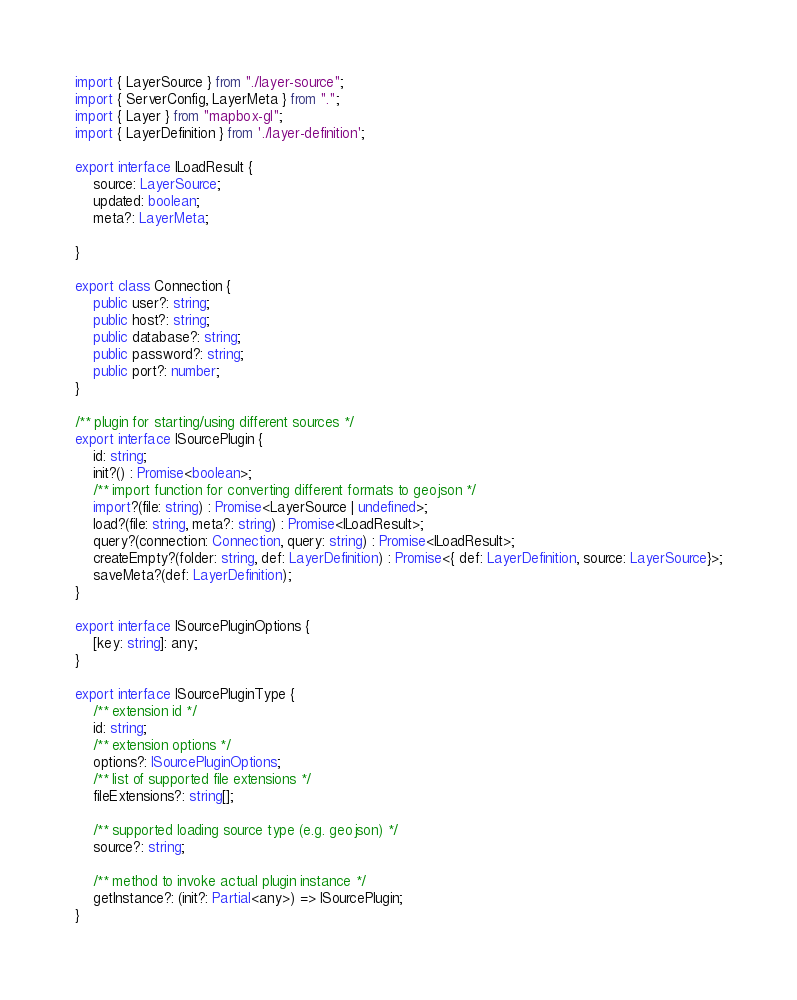<code> <loc_0><loc_0><loc_500><loc_500><_TypeScript_>import { LayerSource } from "./layer-source";
import { ServerConfig, LayerMeta } from ".";
import { Layer } from "mapbox-gl";
import { LayerDefinition } from './layer-definition';

export interface ILoadResult {
    source: LayerSource;
    updated: boolean;
    meta?: LayerMeta;

}

export class Connection {
    public user?: string;
    public host?: string;
    public database?: string;
    public password?: string;
    public port?: number;    
}

/** plugin for starting/using different sources */
export interface ISourcePlugin {
    id: string;
    init?() : Promise<boolean>;  
    /** import function for converting different formats to geojson */  
    import?(file: string) : Promise<LayerSource | undefined>;
    load?(file: string, meta?: string) : Promise<ILoadResult>;
    query?(connection: Connection, query: string) : Promise<ILoadResult>;
    createEmpty?(folder: string, def: LayerDefinition) : Promise<{ def: LayerDefinition, source: LayerSource}>;
    saveMeta?(def: LayerDefinition);
}

export interface ISourcePluginOptions {
    [key: string]: any;
}

export interface ISourcePluginType {
    /** extension id */
    id: string;
    /** extension options */
    options?: ISourcePluginOptions;
    /** list of supported file extensions */
    fileExtensions?: string[];

    /** supported loading source type (e.g. geojson) */
    source?: string;

    /** method to invoke actual plugin instance */
    getInstance?: (init?: Partial<any>) => ISourcePlugin;
}
</code> 